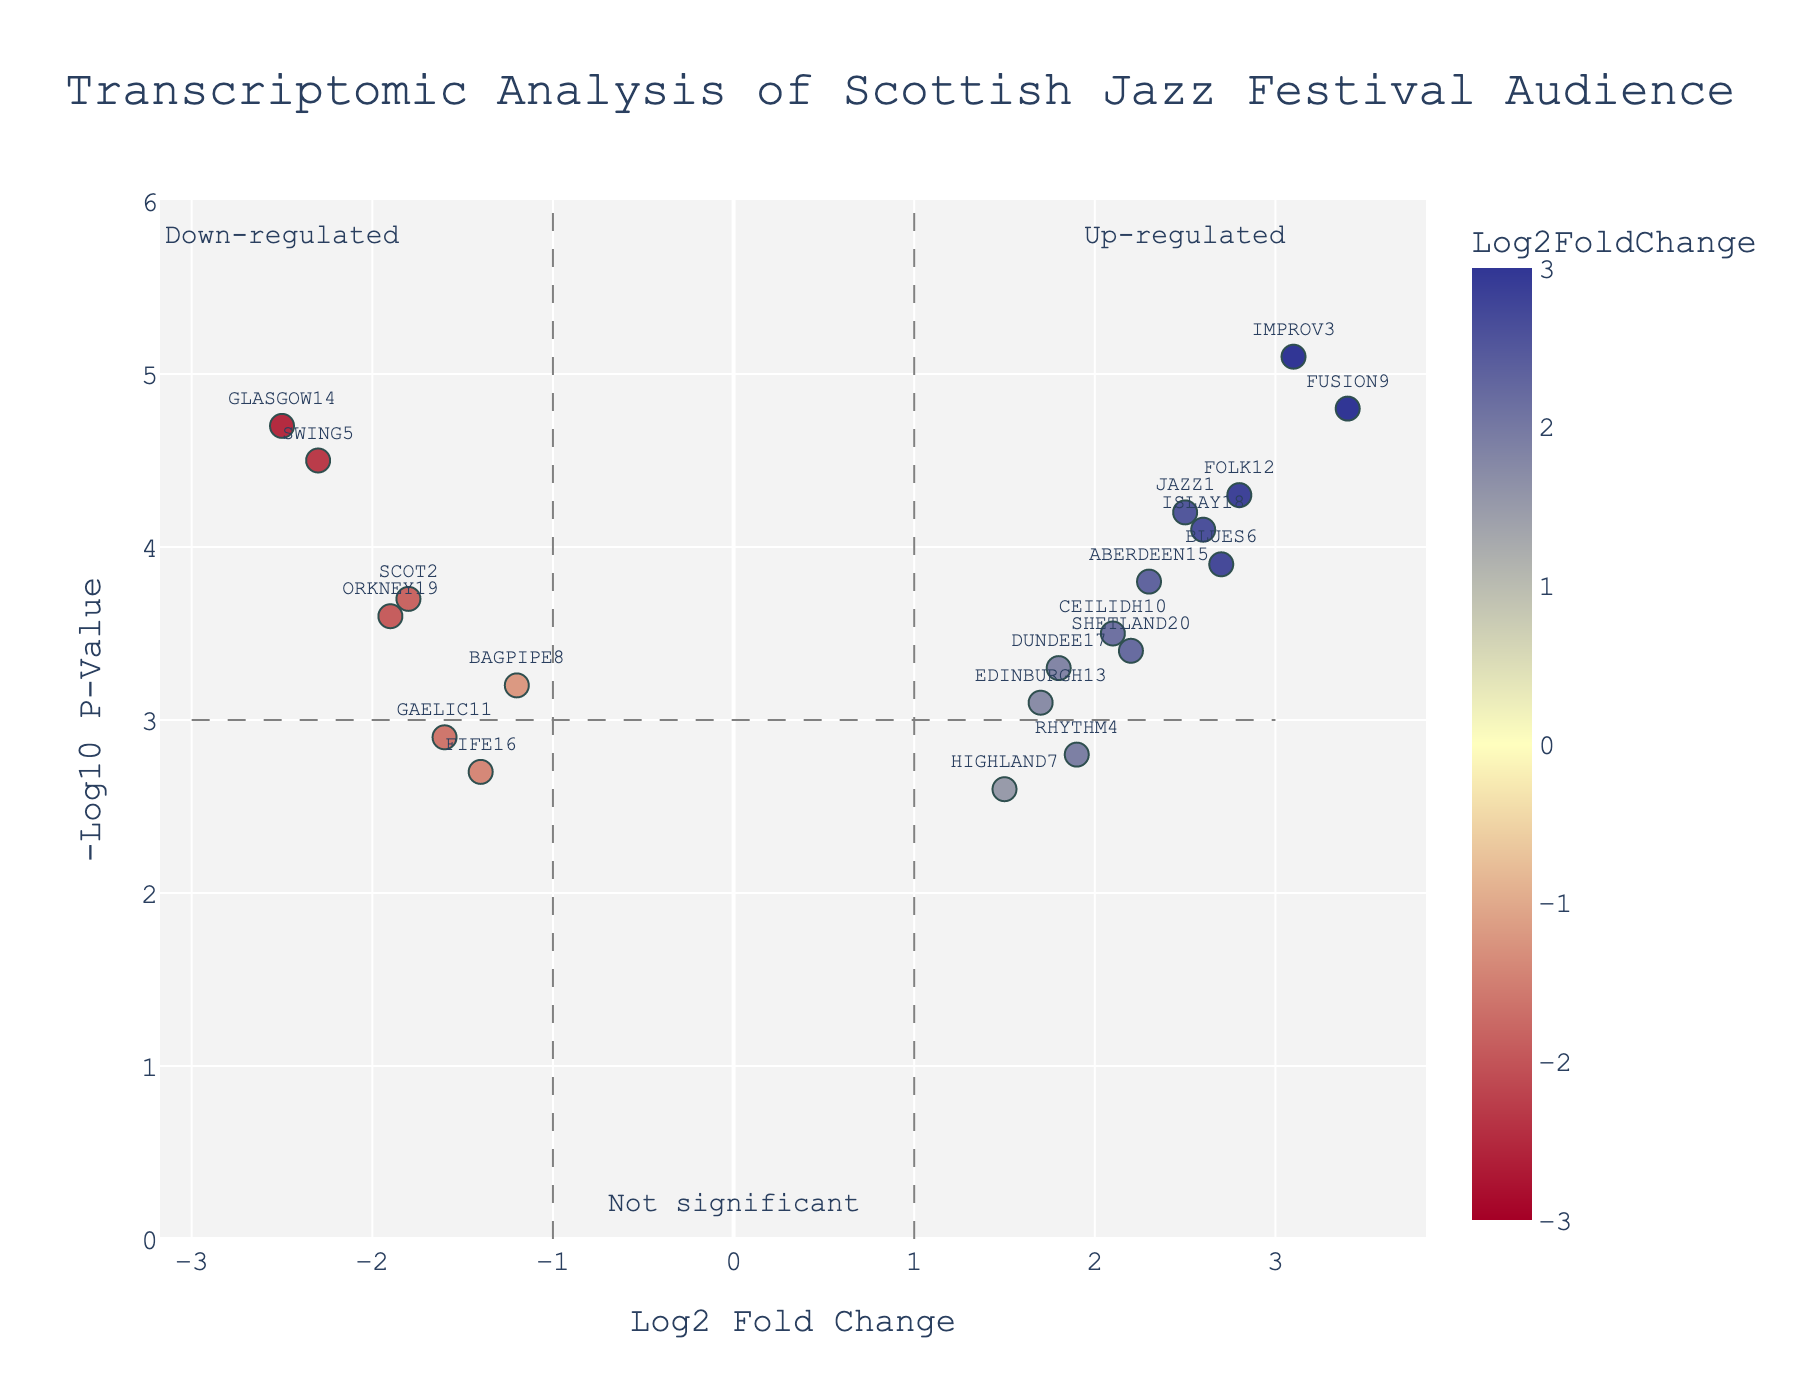What's the title of the plot? The title is written at the top center of the figure, representing the subject matter of the plot.
Answer: Transcriptomic Analysis of Scottish Jazz Festival Audience What are the labels of the x-axis and y-axis? The x-axis label is at the bottom of the figure, and the y-axis label is on the left side of the figure.
Answer: Log2 Fold Change, -Log10 P-Value How many genes are displayed in the plot? By counting the number of unique data points, each representing a gene, on the plot.
Answer: 20 Which gene shows the highest up-regulation? Look for the data point furthest to the right along the x-axis (highest positive Log2FoldChange value) and then identify the gene label.
Answer: FUSION9 Which gene has the most significant down-regulation? Identify the data point with the lowest Log2FoldChange value (most negative) and the highest value on the y-axis (most significant p-value) and then specify the gene.
Answer: GLASGOW14 How many genes are considered significant based on the given thresholds in the plot? Look for data points that are beyond the vertical and horizontal dashed lines, indicating significance in up-regulation or down-regulation.
Answer: 11 What Log2FoldChange value separates up-regulated genes from down-regulated genes in the plot? Refer to the vertical dashed lines that serve as thresholds for up-regulation and down-regulation on the x-axis.
Answer: 1 and -1 Which gene has the lowest -Log10 P-Value among the up-regulated genes? Identify the data point among up-regulated genes (positive Log2FoldChange) with the smallest value on the y-axis (-Log10 P-Value), which indicates less significance.
Answer: RHYTHM4 How many genes lie in the "Not significant" region? Count the number of data points within the boundaries defined as "Not significant" by the annotation on the plot.
Answer: 9 